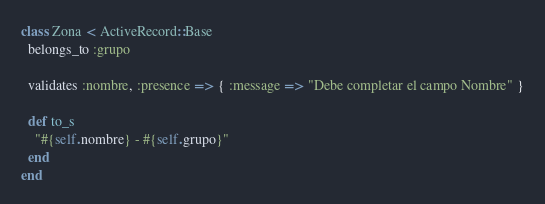<code> <loc_0><loc_0><loc_500><loc_500><_Ruby_>class Zona < ActiveRecord::Base
  belongs_to :grupo

  validates :nombre, :presence => { :message => "Debe completar el campo Nombre" }

  def to_s
  	"#{self.nombre} - #{self.grupo}"
  end
end
</code> 